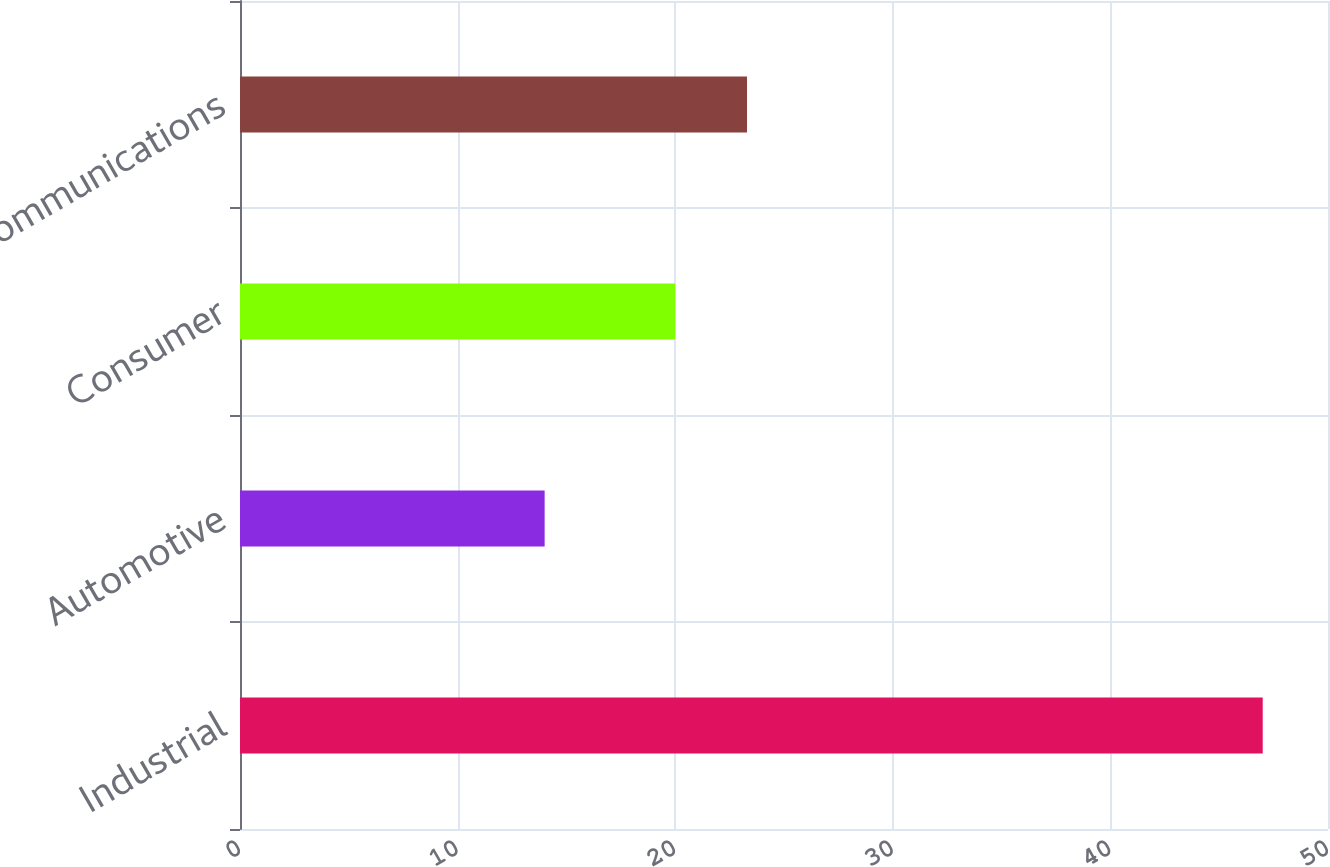Convert chart. <chart><loc_0><loc_0><loc_500><loc_500><bar_chart><fcel>Industrial<fcel>Automotive<fcel>Consumer<fcel>Communications<nl><fcel>47<fcel>14<fcel>20<fcel>23.3<nl></chart> 